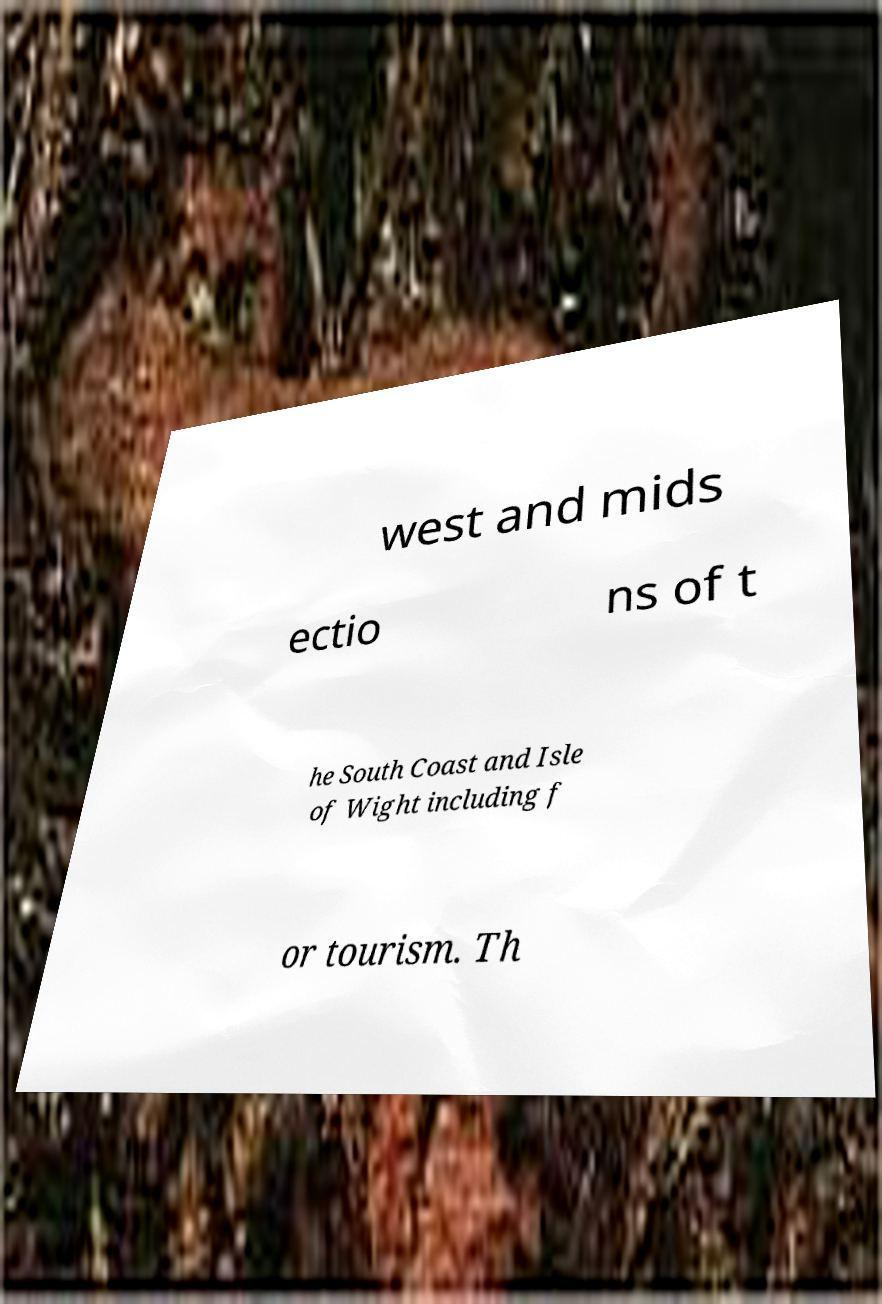Please read and relay the text visible in this image. What does it say? west and mids ectio ns of t he South Coast and Isle of Wight including f or tourism. Th 